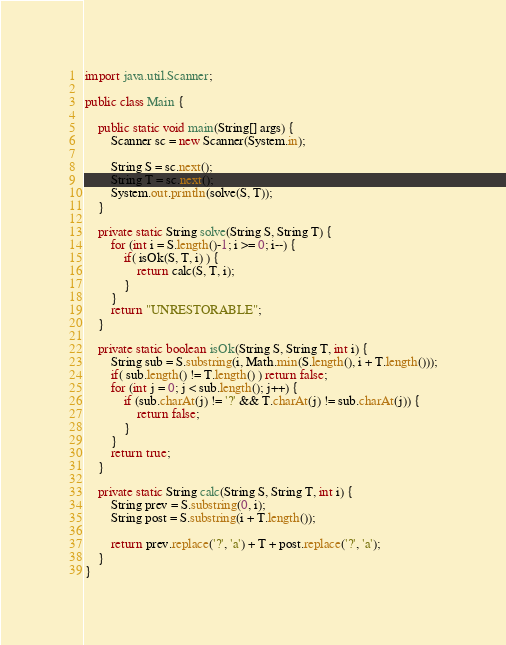<code> <loc_0><loc_0><loc_500><loc_500><_Java_>import java.util.Scanner;

public class Main {

    public static void main(String[] args) {
        Scanner sc = new Scanner(System.in);

        String S = sc.next();
        String T = sc.next();
        System.out.println(solve(S, T));
    }

    private static String solve(String S, String T) {
        for (int i = S.length()-1; i >= 0; i--) {
            if( isOk(S, T, i) ) {
                return calc(S, T, i);
            }
        }
        return "UNRESTORABLE";
    }

    private static boolean isOk(String S, String T, int i) {
        String sub = S.substring(i, Math.min(S.length(), i + T.length()));
        if( sub.length() != T.length() ) return false;
        for (int j = 0; j < sub.length(); j++) {
            if (sub.charAt(j) != '?' && T.charAt(j) != sub.charAt(j)) {
                return false;
            }
        }
        return true;
    }

    private static String calc(String S, String T, int i) {
        String prev = S.substring(0, i);
        String post = S.substring(i + T.length());

        return prev.replace('?', 'a') + T + post.replace('?', 'a');
    }
}
</code> 